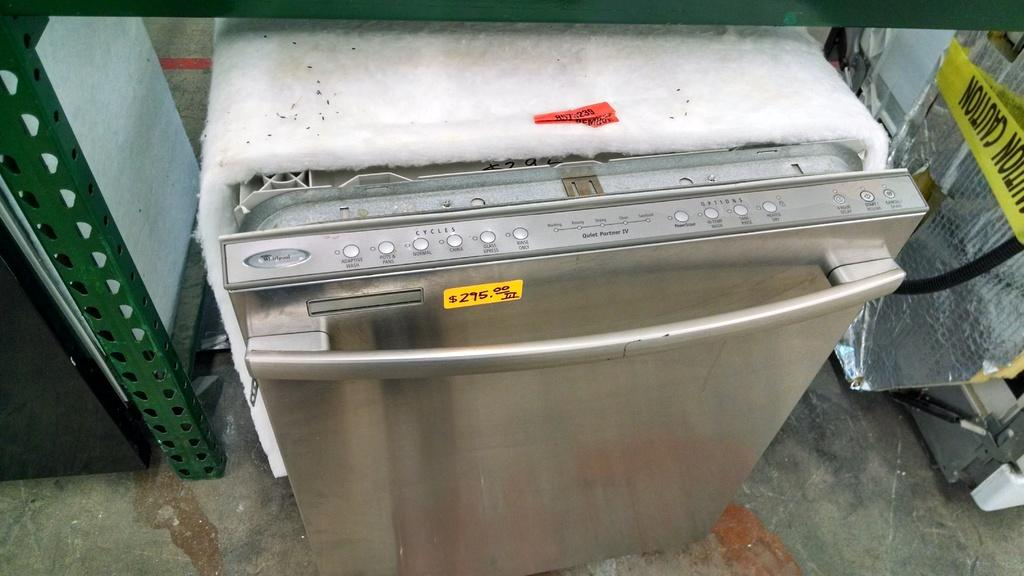<image>
Render a clear and concise summary of the photo. A silver Whirlpool dishwasher on sale for $295 